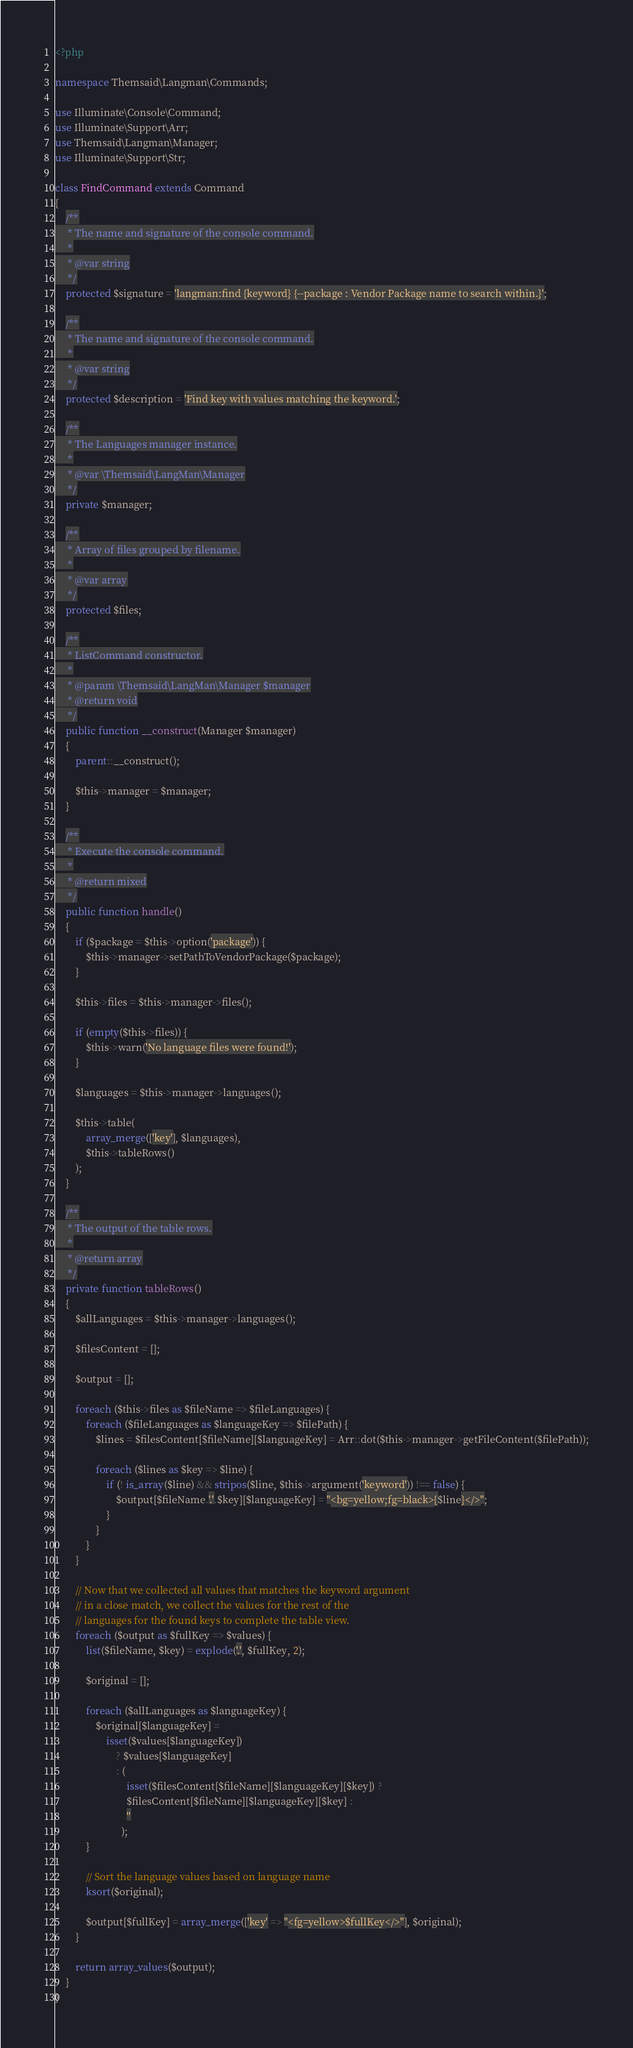<code> <loc_0><loc_0><loc_500><loc_500><_PHP_><?php

namespace Themsaid\Langman\Commands;

use Illuminate\Console\Command;
use Illuminate\Support\Arr;
use Themsaid\Langman\Manager;
use Illuminate\Support\Str;

class FindCommand extends Command
{
    /**
     * The name and signature of the console command.
     *
     * @var string
     */
    protected $signature = 'langman:find {keyword} {--package : Vendor Package name to search within.}';

    /**
     * The name and signature of the console command.
     *
     * @var string
     */
    protected $description = 'Find key with values matching the keyword.';

    /**
     * The Languages manager instance.
     *
     * @var \Themsaid\LangMan\Manager
     */
    private $manager;

    /**
     * Array of files grouped by filename.
     *
     * @var array
     */
    protected $files;

    /**
     * ListCommand constructor.
     *
     * @param \Themsaid\LangMan\Manager $manager
     * @return void
     */
    public function __construct(Manager $manager)
    {
        parent::__construct();

        $this->manager = $manager;
    }

    /**
     * Execute the console command.
     *
     * @return mixed
     */
    public function handle()
    {
        if ($package = $this->option('package')) {
            $this->manager->setPathToVendorPackage($package);
        }

        $this->files = $this->manager->files();

        if (empty($this->files)) {
            $this->warn('No language files were found!');
        }

        $languages = $this->manager->languages();

        $this->table(
            array_merge(['key'], $languages),
            $this->tableRows()
        );
    }

    /**
     * The output of the table rows.
     *
     * @return array
     */
    private function tableRows()
    {
        $allLanguages = $this->manager->languages();

        $filesContent = [];

        $output = [];

        foreach ($this->files as $fileName => $fileLanguages) {
            foreach ($fileLanguages as $languageKey => $filePath) {
                $lines = $filesContent[$fileName][$languageKey] = Arr::dot($this->manager->getFileContent($filePath));

                foreach ($lines as $key => $line) {
                    if (! is_array($line) && stripos($line, $this->argument('keyword')) !== false) {
                        $output[$fileName.'.'.$key][$languageKey] = "<bg=yellow;fg=black>{$line}</>";
                    }
                }
            }
        }

        // Now that we collected all values that matches the keyword argument
        // in a close match, we collect the values for the rest of the
        // languages for the found keys to complete the table view.
        foreach ($output as $fullKey => $values) {
            list($fileName, $key) = explode('.', $fullKey, 2);

            $original = [];

            foreach ($allLanguages as $languageKey) {
                $original[$languageKey] =
                    isset($values[$languageKey])
                        ? $values[$languageKey]
                        : (
                            isset($filesContent[$fileName][$languageKey][$key]) ? 
                            $filesContent[$fileName][$languageKey][$key] : 
                            ''
                          );
            }

            // Sort the language values based on language name
            ksort($original);

            $output[$fullKey] = array_merge(['key' => "<fg=yellow>$fullKey</>"], $original);
        }

        return array_values($output);
    }
}
</code> 